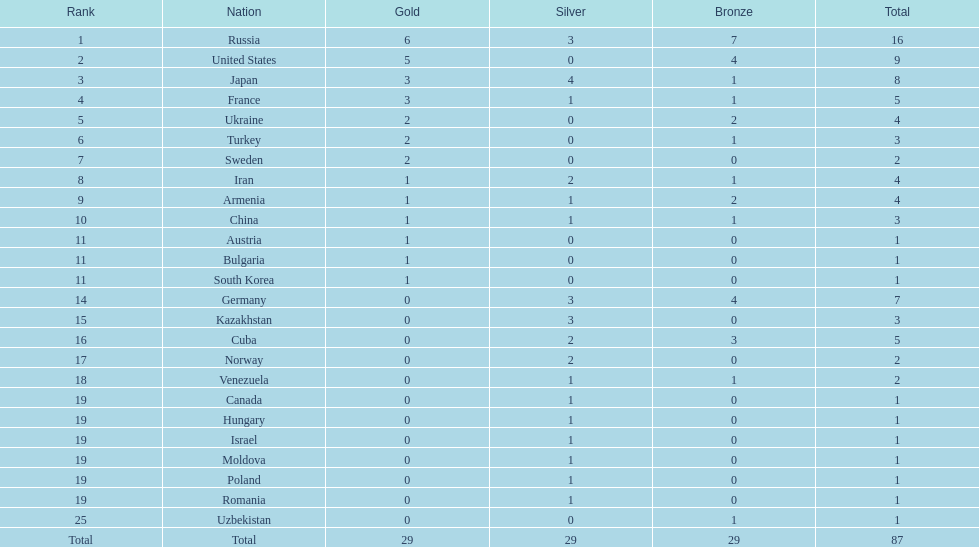Which state was not among the top 10, iran or germany? Germany. Write the full table. {'header': ['Rank', 'Nation', 'Gold', 'Silver', 'Bronze', 'Total'], 'rows': [['1', 'Russia', '6', '3', '7', '16'], ['2', 'United States', '5', '0', '4', '9'], ['3', 'Japan', '3', '4', '1', '8'], ['4', 'France', '3', '1', '1', '5'], ['5', 'Ukraine', '2', '0', '2', '4'], ['6', 'Turkey', '2', '0', '1', '3'], ['7', 'Sweden', '2', '0', '0', '2'], ['8', 'Iran', '1', '2', '1', '4'], ['9', 'Armenia', '1', '1', '2', '4'], ['10', 'China', '1', '1', '1', '3'], ['11', 'Austria', '1', '0', '0', '1'], ['11', 'Bulgaria', '1', '0', '0', '1'], ['11', 'South Korea', '1', '0', '0', '1'], ['14', 'Germany', '0', '3', '4', '7'], ['15', 'Kazakhstan', '0', '3', '0', '3'], ['16', 'Cuba', '0', '2', '3', '5'], ['17', 'Norway', '0', '2', '0', '2'], ['18', 'Venezuela', '0', '1', '1', '2'], ['19', 'Canada', '0', '1', '0', '1'], ['19', 'Hungary', '0', '1', '0', '1'], ['19', 'Israel', '0', '1', '0', '1'], ['19', 'Moldova', '0', '1', '0', '1'], ['19', 'Poland', '0', '1', '0', '1'], ['19', 'Romania', '0', '1', '0', '1'], ['25', 'Uzbekistan', '0', '0', '1', '1'], ['Total', 'Total', '29', '29', '29', '87']]} 